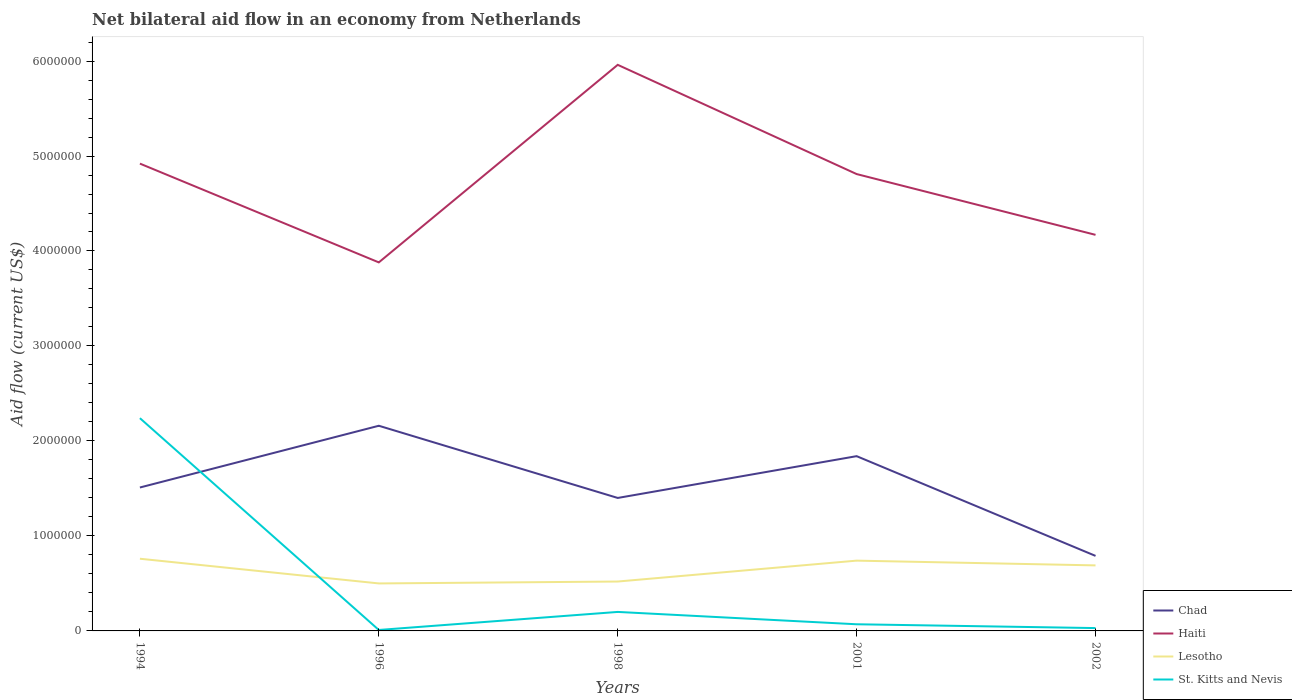How many different coloured lines are there?
Provide a short and direct response. 4. Is the number of lines equal to the number of legend labels?
Your response must be concise. Yes. Across all years, what is the maximum net bilateral aid flow in Haiti?
Provide a succinct answer. 3.88e+06. In which year was the net bilateral aid flow in Haiti maximum?
Keep it short and to the point. 1996. What is the total net bilateral aid flow in St. Kitts and Nevis in the graph?
Make the answer very short. 1.70e+05. What is the difference between the highest and the second highest net bilateral aid flow in St. Kitts and Nevis?
Offer a very short reply. 2.23e+06. What is the difference between the highest and the lowest net bilateral aid flow in Haiti?
Provide a succinct answer. 3. How many years are there in the graph?
Offer a terse response. 5. How many legend labels are there?
Offer a very short reply. 4. How are the legend labels stacked?
Your answer should be compact. Vertical. What is the title of the graph?
Ensure brevity in your answer.  Net bilateral aid flow in an economy from Netherlands. Does "Trinidad and Tobago" appear as one of the legend labels in the graph?
Keep it short and to the point. No. What is the label or title of the Y-axis?
Provide a short and direct response. Aid flow (current US$). What is the Aid flow (current US$) in Chad in 1994?
Ensure brevity in your answer.  1.51e+06. What is the Aid flow (current US$) in Haiti in 1994?
Offer a very short reply. 4.92e+06. What is the Aid flow (current US$) of Lesotho in 1994?
Your answer should be compact. 7.60e+05. What is the Aid flow (current US$) of St. Kitts and Nevis in 1994?
Give a very brief answer. 2.24e+06. What is the Aid flow (current US$) of Chad in 1996?
Offer a very short reply. 2.16e+06. What is the Aid flow (current US$) of Haiti in 1996?
Your answer should be very brief. 3.88e+06. What is the Aid flow (current US$) in Lesotho in 1996?
Your response must be concise. 5.00e+05. What is the Aid flow (current US$) in St. Kitts and Nevis in 1996?
Your response must be concise. 10000. What is the Aid flow (current US$) in Chad in 1998?
Give a very brief answer. 1.40e+06. What is the Aid flow (current US$) of Haiti in 1998?
Provide a succinct answer. 5.96e+06. What is the Aid flow (current US$) in Lesotho in 1998?
Offer a terse response. 5.20e+05. What is the Aid flow (current US$) of St. Kitts and Nevis in 1998?
Make the answer very short. 2.00e+05. What is the Aid flow (current US$) in Chad in 2001?
Provide a short and direct response. 1.84e+06. What is the Aid flow (current US$) in Haiti in 2001?
Provide a short and direct response. 4.81e+06. What is the Aid flow (current US$) in Lesotho in 2001?
Offer a terse response. 7.40e+05. What is the Aid flow (current US$) in Chad in 2002?
Provide a succinct answer. 7.90e+05. What is the Aid flow (current US$) in Haiti in 2002?
Provide a short and direct response. 4.17e+06. What is the Aid flow (current US$) in Lesotho in 2002?
Your answer should be compact. 6.90e+05. Across all years, what is the maximum Aid flow (current US$) of Chad?
Your response must be concise. 2.16e+06. Across all years, what is the maximum Aid flow (current US$) of Haiti?
Your response must be concise. 5.96e+06. Across all years, what is the maximum Aid flow (current US$) in Lesotho?
Provide a short and direct response. 7.60e+05. Across all years, what is the maximum Aid flow (current US$) in St. Kitts and Nevis?
Offer a very short reply. 2.24e+06. Across all years, what is the minimum Aid flow (current US$) in Chad?
Provide a succinct answer. 7.90e+05. Across all years, what is the minimum Aid flow (current US$) of Haiti?
Give a very brief answer. 3.88e+06. Across all years, what is the minimum Aid flow (current US$) in Lesotho?
Your answer should be very brief. 5.00e+05. What is the total Aid flow (current US$) in Chad in the graph?
Offer a very short reply. 7.70e+06. What is the total Aid flow (current US$) of Haiti in the graph?
Your answer should be very brief. 2.37e+07. What is the total Aid flow (current US$) in Lesotho in the graph?
Your response must be concise. 3.21e+06. What is the total Aid flow (current US$) of St. Kitts and Nevis in the graph?
Your response must be concise. 2.55e+06. What is the difference between the Aid flow (current US$) in Chad in 1994 and that in 1996?
Make the answer very short. -6.50e+05. What is the difference between the Aid flow (current US$) of Haiti in 1994 and that in 1996?
Provide a short and direct response. 1.04e+06. What is the difference between the Aid flow (current US$) in St. Kitts and Nevis in 1994 and that in 1996?
Provide a succinct answer. 2.23e+06. What is the difference between the Aid flow (current US$) of Chad in 1994 and that in 1998?
Offer a terse response. 1.10e+05. What is the difference between the Aid flow (current US$) in Haiti in 1994 and that in 1998?
Make the answer very short. -1.04e+06. What is the difference between the Aid flow (current US$) of St. Kitts and Nevis in 1994 and that in 1998?
Provide a short and direct response. 2.04e+06. What is the difference between the Aid flow (current US$) of Chad in 1994 and that in 2001?
Your answer should be very brief. -3.30e+05. What is the difference between the Aid flow (current US$) of Haiti in 1994 and that in 2001?
Offer a very short reply. 1.10e+05. What is the difference between the Aid flow (current US$) in Lesotho in 1994 and that in 2001?
Make the answer very short. 2.00e+04. What is the difference between the Aid flow (current US$) of St. Kitts and Nevis in 1994 and that in 2001?
Offer a terse response. 2.17e+06. What is the difference between the Aid flow (current US$) in Chad in 1994 and that in 2002?
Your answer should be very brief. 7.20e+05. What is the difference between the Aid flow (current US$) in Haiti in 1994 and that in 2002?
Ensure brevity in your answer.  7.50e+05. What is the difference between the Aid flow (current US$) of Lesotho in 1994 and that in 2002?
Offer a terse response. 7.00e+04. What is the difference between the Aid flow (current US$) in St. Kitts and Nevis in 1994 and that in 2002?
Provide a succinct answer. 2.21e+06. What is the difference between the Aid flow (current US$) of Chad in 1996 and that in 1998?
Provide a succinct answer. 7.60e+05. What is the difference between the Aid flow (current US$) of Haiti in 1996 and that in 1998?
Provide a succinct answer. -2.08e+06. What is the difference between the Aid flow (current US$) of Lesotho in 1996 and that in 1998?
Give a very brief answer. -2.00e+04. What is the difference between the Aid flow (current US$) of St. Kitts and Nevis in 1996 and that in 1998?
Offer a terse response. -1.90e+05. What is the difference between the Aid flow (current US$) of Chad in 1996 and that in 2001?
Your response must be concise. 3.20e+05. What is the difference between the Aid flow (current US$) of Haiti in 1996 and that in 2001?
Give a very brief answer. -9.30e+05. What is the difference between the Aid flow (current US$) in Lesotho in 1996 and that in 2001?
Your answer should be compact. -2.40e+05. What is the difference between the Aid flow (current US$) of Chad in 1996 and that in 2002?
Keep it short and to the point. 1.37e+06. What is the difference between the Aid flow (current US$) of Haiti in 1996 and that in 2002?
Give a very brief answer. -2.90e+05. What is the difference between the Aid flow (current US$) of Lesotho in 1996 and that in 2002?
Provide a succinct answer. -1.90e+05. What is the difference between the Aid flow (current US$) in Chad in 1998 and that in 2001?
Provide a short and direct response. -4.40e+05. What is the difference between the Aid flow (current US$) of Haiti in 1998 and that in 2001?
Your answer should be very brief. 1.15e+06. What is the difference between the Aid flow (current US$) in Lesotho in 1998 and that in 2001?
Your response must be concise. -2.20e+05. What is the difference between the Aid flow (current US$) in Chad in 1998 and that in 2002?
Make the answer very short. 6.10e+05. What is the difference between the Aid flow (current US$) in Haiti in 1998 and that in 2002?
Your answer should be compact. 1.79e+06. What is the difference between the Aid flow (current US$) of St. Kitts and Nevis in 1998 and that in 2002?
Provide a short and direct response. 1.70e+05. What is the difference between the Aid flow (current US$) of Chad in 2001 and that in 2002?
Keep it short and to the point. 1.05e+06. What is the difference between the Aid flow (current US$) in Haiti in 2001 and that in 2002?
Your answer should be compact. 6.40e+05. What is the difference between the Aid flow (current US$) of St. Kitts and Nevis in 2001 and that in 2002?
Your response must be concise. 4.00e+04. What is the difference between the Aid flow (current US$) in Chad in 1994 and the Aid flow (current US$) in Haiti in 1996?
Make the answer very short. -2.37e+06. What is the difference between the Aid flow (current US$) of Chad in 1994 and the Aid flow (current US$) of Lesotho in 1996?
Keep it short and to the point. 1.01e+06. What is the difference between the Aid flow (current US$) in Chad in 1994 and the Aid flow (current US$) in St. Kitts and Nevis in 1996?
Provide a short and direct response. 1.50e+06. What is the difference between the Aid flow (current US$) in Haiti in 1994 and the Aid flow (current US$) in Lesotho in 1996?
Offer a terse response. 4.42e+06. What is the difference between the Aid flow (current US$) in Haiti in 1994 and the Aid flow (current US$) in St. Kitts and Nevis in 1996?
Keep it short and to the point. 4.91e+06. What is the difference between the Aid flow (current US$) in Lesotho in 1994 and the Aid flow (current US$) in St. Kitts and Nevis in 1996?
Your response must be concise. 7.50e+05. What is the difference between the Aid flow (current US$) in Chad in 1994 and the Aid flow (current US$) in Haiti in 1998?
Give a very brief answer. -4.45e+06. What is the difference between the Aid flow (current US$) of Chad in 1994 and the Aid flow (current US$) of Lesotho in 1998?
Keep it short and to the point. 9.90e+05. What is the difference between the Aid flow (current US$) of Chad in 1994 and the Aid flow (current US$) of St. Kitts and Nevis in 1998?
Provide a succinct answer. 1.31e+06. What is the difference between the Aid flow (current US$) of Haiti in 1994 and the Aid flow (current US$) of Lesotho in 1998?
Your answer should be very brief. 4.40e+06. What is the difference between the Aid flow (current US$) in Haiti in 1994 and the Aid flow (current US$) in St. Kitts and Nevis in 1998?
Your answer should be very brief. 4.72e+06. What is the difference between the Aid flow (current US$) in Lesotho in 1994 and the Aid flow (current US$) in St. Kitts and Nevis in 1998?
Give a very brief answer. 5.60e+05. What is the difference between the Aid flow (current US$) in Chad in 1994 and the Aid flow (current US$) in Haiti in 2001?
Keep it short and to the point. -3.30e+06. What is the difference between the Aid flow (current US$) in Chad in 1994 and the Aid flow (current US$) in Lesotho in 2001?
Provide a short and direct response. 7.70e+05. What is the difference between the Aid flow (current US$) of Chad in 1994 and the Aid flow (current US$) of St. Kitts and Nevis in 2001?
Provide a succinct answer. 1.44e+06. What is the difference between the Aid flow (current US$) of Haiti in 1994 and the Aid flow (current US$) of Lesotho in 2001?
Provide a short and direct response. 4.18e+06. What is the difference between the Aid flow (current US$) in Haiti in 1994 and the Aid flow (current US$) in St. Kitts and Nevis in 2001?
Provide a short and direct response. 4.85e+06. What is the difference between the Aid flow (current US$) of Lesotho in 1994 and the Aid flow (current US$) of St. Kitts and Nevis in 2001?
Give a very brief answer. 6.90e+05. What is the difference between the Aid flow (current US$) in Chad in 1994 and the Aid flow (current US$) in Haiti in 2002?
Give a very brief answer. -2.66e+06. What is the difference between the Aid flow (current US$) of Chad in 1994 and the Aid flow (current US$) of Lesotho in 2002?
Your answer should be compact. 8.20e+05. What is the difference between the Aid flow (current US$) of Chad in 1994 and the Aid flow (current US$) of St. Kitts and Nevis in 2002?
Offer a very short reply. 1.48e+06. What is the difference between the Aid flow (current US$) of Haiti in 1994 and the Aid flow (current US$) of Lesotho in 2002?
Keep it short and to the point. 4.23e+06. What is the difference between the Aid flow (current US$) in Haiti in 1994 and the Aid flow (current US$) in St. Kitts and Nevis in 2002?
Offer a very short reply. 4.89e+06. What is the difference between the Aid flow (current US$) of Lesotho in 1994 and the Aid flow (current US$) of St. Kitts and Nevis in 2002?
Make the answer very short. 7.30e+05. What is the difference between the Aid flow (current US$) of Chad in 1996 and the Aid flow (current US$) of Haiti in 1998?
Your response must be concise. -3.80e+06. What is the difference between the Aid flow (current US$) of Chad in 1996 and the Aid flow (current US$) of Lesotho in 1998?
Provide a succinct answer. 1.64e+06. What is the difference between the Aid flow (current US$) of Chad in 1996 and the Aid flow (current US$) of St. Kitts and Nevis in 1998?
Offer a very short reply. 1.96e+06. What is the difference between the Aid flow (current US$) of Haiti in 1996 and the Aid flow (current US$) of Lesotho in 1998?
Provide a succinct answer. 3.36e+06. What is the difference between the Aid flow (current US$) of Haiti in 1996 and the Aid flow (current US$) of St. Kitts and Nevis in 1998?
Provide a succinct answer. 3.68e+06. What is the difference between the Aid flow (current US$) in Lesotho in 1996 and the Aid flow (current US$) in St. Kitts and Nevis in 1998?
Your answer should be very brief. 3.00e+05. What is the difference between the Aid flow (current US$) in Chad in 1996 and the Aid flow (current US$) in Haiti in 2001?
Offer a very short reply. -2.65e+06. What is the difference between the Aid flow (current US$) in Chad in 1996 and the Aid flow (current US$) in Lesotho in 2001?
Give a very brief answer. 1.42e+06. What is the difference between the Aid flow (current US$) of Chad in 1996 and the Aid flow (current US$) of St. Kitts and Nevis in 2001?
Make the answer very short. 2.09e+06. What is the difference between the Aid flow (current US$) in Haiti in 1996 and the Aid flow (current US$) in Lesotho in 2001?
Provide a short and direct response. 3.14e+06. What is the difference between the Aid flow (current US$) of Haiti in 1996 and the Aid flow (current US$) of St. Kitts and Nevis in 2001?
Your response must be concise. 3.81e+06. What is the difference between the Aid flow (current US$) in Lesotho in 1996 and the Aid flow (current US$) in St. Kitts and Nevis in 2001?
Provide a succinct answer. 4.30e+05. What is the difference between the Aid flow (current US$) in Chad in 1996 and the Aid flow (current US$) in Haiti in 2002?
Offer a very short reply. -2.01e+06. What is the difference between the Aid flow (current US$) in Chad in 1996 and the Aid flow (current US$) in Lesotho in 2002?
Offer a very short reply. 1.47e+06. What is the difference between the Aid flow (current US$) in Chad in 1996 and the Aid flow (current US$) in St. Kitts and Nevis in 2002?
Ensure brevity in your answer.  2.13e+06. What is the difference between the Aid flow (current US$) of Haiti in 1996 and the Aid flow (current US$) of Lesotho in 2002?
Ensure brevity in your answer.  3.19e+06. What is the difference between the Aid flow (current US$) in Haiti in 1996 and the Aid flow (current US$) in St. Kitts and Nevis in 2002?
Ensure brevity in your answer.  3.85e+06. What is the difference between the Aid flow (current US$) in Chad in 1998 and the Aid flow (current US$) in Haiti in 2001?
Give a very brief answer. -3.41e+06. What is the difference between the Aid flow (current US$) of Chad in 1998 and the Aid flow (current US$) of St. Kitts and Nevis in 2001?
Give a very brief answer. 1.33e+06. What is the difference between the Aid flow (current US$) in Haiti in 1998 and the Aid flow (current US$) in Lesotho in 2001?
Keep it short and to the point. 5.22e+06. What is the difference between the Aid flow (current US$) in Haiti in 1998 and the Aid flow (current US$) in St. Kitts and Nevis in 2001?
Offer a very short reply. 5.89e+06. What is the difference between the Aid flow (current US$) in Chad in 1998 and the Aid flow (current US$) in Haiti in 2002?
Offer a terse response. -2.77e+06. What is the difference between the Aid flow (current US$) in Chad in 1998 and the Aid flow (current US$) in Lesotho in 2002?
Your answer should be very brief. 7.10e+05. What is the difference between the Aid flow (current US$) in Chad in 1998 and the Aid flow (current US$) in St. Kitts and Nevis in 2002?
Ensure brevity in your answer.  1.37e+06. What is the difference between the Aid flow (current US$) of Haiti in 1998 and the Aid flow (current US$) of Lesotho in 2002?
Offer a very short reply. 5.27e+06. What is the difference between the Aid flow (current US$) in Haiti in 1998 and the Aid flow (current US$) in St. Kitts and Nevis in 2002?
Keep it short and to the point. 5.93e+06. What is the difference between the Aid flow (current US$) in Lesotho in 1998 and the Aid flow (current US$) in St. Kitts and Nevis in 2002?
Your answer should be compact. 4.90e+05. What is the difference between the Aid flow (current US$) of Chad in 2001 and the Aid flow (current US$) of Haiti in 2002?
Your answer should be very brief. -2.33e+06. What is the difference between the Aid flow (current US$) in Chad in 2001 and the Aid flow (current US$) in Lesotho in 2002?
Make the answer very short. 1.15e+06. What is the difference between the Aid flow (current US$) of Chad in 2001 and the Aid flow (current US$) of St. Kitts and Nevis in 2002?
Ensure brevity in your answer.  1.81e+06. What is the difference between the Aid flow (current US$) of Haiti in 2001 and the Aid flow (current US$) of Lesotho in 2002?
Your response must be concise. 4.12e+06. What is the difference between the Aid flow (current US$) in Haiti in 2001 and the Aid flow (current US$) in St. Kitts and Nevis in 2002?
Keep it short and to the point. 4.78e+06. What is the difference between the Aid flow (current US$) in Lesotho in 2001 and the Aid flow (current US$) in St. Kitts and Nevis in 2002?
Make the answer very short. 7.10e+05. What is the average Aid flow (current US$) of Chad per year?
Ensure brevity in your answer.  1.54e+06. What is the average Aid flow (current US$) in Haiti per year?
Offer a terse response. 4.75e+06. What is the average Aid flow (current US$) of Lesotho per year?
Offer a terse response. 6.42e+05. What is the average Aid flow (current US$) of St. Kitts and Nevis per year?
Keep it short and to the point. 5.10e+05. In the year 1994, what is the difference between the Aid flow (current US$) in Chad and Aid flow (current US$) in Haiti?
Make the answer very short. -3.41e+06. In the year 1994, what is the difference between the Aid flow (current US$) in Chad and Aid flow (current US$) in Lesotho?
Keep it short and to the point. 7.50e+05. In the year 1994, what is the difference between the Aid flow (current US$) of Chad and Aid flow (current US$) of St. Kitts and Nevis?
Keep it short and to the point. -7.30e+05. In the year 1994, what is the difference between the Aid flow (current US$) of Haiti and Aid flow (current US$) of Lesotho?
Make the answer very short. 4.16e+06. In the year 1994, what is the difference between the Aid flow (current US$) of Haiti and Aid flow (current US$) of St. Kitts and Nevis?
Your answer should be compact. 2.68e+06. In the year 1994, what is the difference between the Aid flow (current US$) in Lesotho and Aid flow (current US$) in St. Kitts and Nevis?
Your answer should be compact. -1.48e+06. In the year 1996, what is the difference between the Aid flow (current US$) in Chad and Aid flow (current US$) in Haiti?
Keep it short and to the point. -1.72e+06. In the year 1996, what is the difference between the Aid flow (current US$) of Chad and Aid flow (current US$) of Lesotho?
Your response must be concise. 1.66e+06. In the year 1996, what is the difference between the Aid flow (current US$) in Chad and Aid flow (current US$) in St. Kitts and Nevis?
Provide a succinct answer. 2.15e+06. In the year 1996, what is the difference between the Aid flow (current US$) in Haiti and Aid flow (current US$) in Lesotho?
Keep it short and to the point. 3.38e+06. In the year 1996, what is the difference between the Aid flow (current US$) in Haiti and Aid flow (current US$) in St. Kitts and Nevis?
Your answer should be compact. 3.87e+06. In the year 1998, what is the difference between the Aid flow (current US$) of Chad and Aid flow (current US$) of Haiti?
Provide a succinct answer. -4.56e+06. In the year 1998, what is the difference between the Aid flow (current US$) of Chad and Aid flow (current US$) of Lesotho?
Give a very brief answer. 8.80e+05. In the year 1998, what is the difference between the Aid flow (current US$) in Chad and Aid flow (current US$) in St. Kitts and Nevis?
Offer a very short reply. 1.20e+06. In the year 1998, what is the difference between the Aid flow (current US$) of Haiti and Aid flow (current US$) of Lesotho?
Offer a very short reply. 5.44e+06. In the year 1998, what is the difference between the Aid flow (current US$) of Haiti and Aid flow (current US$) of St. Kitts and Nevis?
Offer a terse response. 5.76e+06. In the year 2001, what is the difference between the Aid flow (current US$) in Chad and Aid flow (current US$) in Haiti?
Provide a short and direct response. -2.97e+06. In the year 2001, what is the difference between the Aid flow (current US$) in Chad and Aid flow (current US$) in Lesotho?
Give a very brief answer. 1.10e+06. In the year 2001, what is the difference between the Aid flow (current US$) of Chad and Aid flow (current US$) of St. Kitts and Nevis?
Offer a terse response. 1.77e+06. In the year 2001, what is the difference between the Aid flow (current US$) of Haiti and Aid flow (current US$) of Lesotho?
Your answer should be compact. 4.07e+06. In the year 2001, what is the difference between the Aid flow (current US$) of Haiti and Aid flow (current US$) of St. Kitts and Nevis?
Provide a short and direct response. 4.74e+06. In the year 2001, what is the difference between the Aid flow (current US$) of Lesotho and Aid flow (current US$) of St. Kitts and Nevis?
Give a very brief answer. 6.70e+05. In the year 2002, what is the difference between the Aid flow (current US$) of Chad and Aid flow (current US$) of Haiti?
Provide a short and direct response. -3.38e+06. In the year 2002, what is the difference between the Aid flow (current US$) in Chad and Aid flow (current US$) in Lesotho?
Your answer should be very brief. 1.00e+05. In the year 2002, what is the difference between the Aid flow (current US$) in Chad and Aid flow (current US$) in St. Kitts and Nevis?
Your answer should be very brief. 7.60e+05. In the year 2002, what is the difference between the Aid flow (current US$) of Haiti and Aid flow (current US$) of Lesotho?
Provide a succinct answer. 3.48e+06. In the year 2002, what is the difference between the Aid flow (current US$) of Haiti and Aid flow (current US$) of St. Kitts and Nevis?
Offer a terse response. 4.14e+06. In the year 2002, what is the difference between the Aid flow (current US$) of Lesotho and Aid flow (current US$) of St. Kitts and Nevis?
Offer a very short reply. 6.60e+05. What is the ratio of the Aid flow (current US$) of Chad in 1994 to that in 1996?
Offer a very short reply. 0.7. What is the ratio of the Aid flow (current US$) of Haiti in 1994 to that in 1996?
Offer a terse response. 1.27. What is the ratio of the Aid flow (current US$) of Lesotho in 1994 to that in 1996?
Your response must be concise. 1.52. What is the ratio of the Aid flow (current US$) of St. Kitts and Nevis in 1994 to that in 1996?
Give a very brief answer. 224. What is the ratio of the Aid flow (current US$) of Chad in 1994 to that in 1998?
Keep it short and to the point. 1.08. What is the ratio of the Aid flow (current US$) of Haiti in 1994 to that in 1998?
Give a very brief answer. 0.83. What is the ratio of the Aid flow (current US$) of Lesotho in 1994 to that in 1998?
Your response must be concise. 1.46. What is the ratio of the Aid flow (current US$) in Chad in 1994 to that in 2001?
Your response must be concise. 0.82. What is the ratio of the Aid flow (current US$) of Haiti in 1994 to that in 2001?
Make the answer very short. 1.02. What is the ratio of the Aid flow (current US$) in Lesotho in 1994 to that in 2001?
Provide a succinct answer. 1.03. What is the ratio of the Aid flow (current US$) in Chad in 1994 to that in 2002?
Offer a very short reply. 1.91. What is the ratio of the Aid flow (current US$) of Haiti in 1994 to that in 2002?
Provide a short and direct response. 1.18. What is the ratio of the Aid flow (current US$) of Lesotho in 1994 to that in 2002?
Offer a terse response. 1.1. What is the ratio of the Aid flow (current US$) of St. Kitts and Nevis in 1994 to that in 2002?
Give a very brief answer. 74.67. What is the ratio of the Aid flow (current US$) in Chad in 1996 to that in 1998?
Provide a succinct answer. 1.54. What is the ratio of the Aid flow (current US$) in Haiti in 1996 to that in 1998?
Your answer should be very brief. 0.65. What is the ratio of the Aid flow (current US$) in Lesotho in 1996 to that in 1998?
Your response must be concise. 0.96. What is the ratio of the Aid flow (current US$) of Chad in 1996 to that in 2001?
Make the answer very short. 1.17. What is the ratio of the Aid flow (current US$) in Haiti in 1996 to that in 2001?
Keep it short and to the point. 0.81. What is the ratio of the Aid flow (current US$) in Lesotho in 1996 to that in 2001?
Give a very brief answer. 0.68. What is the ratio of the Aid flow (current US$) of St. Kitts and Nevis in 1996 to that in 2001?
Your response must be concise. 0.14. What is the ratio of the Aid flow (current US$) of Chad in 1996 to that in 2002?
Provide a short and direct response. 2.73. What is the ratio of the Aid flow (current US$) of Haiti in 1996 to that in 2002?
Offer a very short reply. 0.93. What is the ratio of the Aid flow (current US$) of Lesotho in 1996 to that in 2002?
Your response must be concise. 0.72. What is the ratio of the Aid flow (current US$) in Chad in 1998 to that in 2001?
Your answer should be very brief. 0.76. What is the ratio of the Aid flow (current US$) of Haiti in 1998 to that in 2001?
Keep it short and to the point. 1.24. What is the ratio of the Aid flow (current US$) in Lesotho in 1998 to that in 2001?
Give a very brief answer. 0.7. What is the ratio of the Aid flow (current US$) in St. Kitts and Nevis in 1998 to that in 2001?
Make the answer very short. 2.86. What is the ratio of the Aid flow (current US$) in Chad in 1998 to that in 2002?
Keep it short and to the point. 1.77. What is the ratio of the Aid flow (current US$) of Haiti in 1998 to that in 2002?
Keep it short and to the point. 1.43. What is the ratio of the Aid flow (current US$) in Lesotho in 1998 to that in 2002?
Provide a short and direct response. 0.75. What is the ratio of the Aid flow (current US$) of Chad in 2001 to that in 2002?
Ensure brevity in your answer.  2.33. What is the ratio of the Aid flow (current US$) of Haiti in 2001 to that in 2002?
Your answer should be compact. 1.15. What is the ratio of the Aid flow (current US$) in Lesotho in 2001 to that in 2002?
Offer a terse response. 1.07. What is the ratio of the Aid flow (current US$) in St. Kitts and Nevis in 2001 to that in 2002?
Provide a short and direct response. 2.33. What is the difference between the highest and the second highest Aid flow (current US$) in Chad?
Give a very brief answer. 3.20e+05. What is the difference between the highest and the second highest Aid flow (current US$) of Haiti?
Keep it short and to the point. 1.04e+06. What is the difference between the highest and the second highest Aid flow (current US$) in Lesotho?
Offer a very short reply. 2.00e+04. What is the difference between the highest and the second highest Aid flow (current US$) of St. Kitts and Nevis?
Your response must be concise. 2.04e+06. What is the difference between the highest and the lowest Aid flow (current US$) of Chad?
Your answer should be compact. 1.37e+06. What is the difference between the highest and the lowest Aid flow (current US$) of Haiti?
Give a very brief answer. 2.08e+06. What is the difference between the highest and the lowest Aid flow (current US$) of St. Kitts and Nevis?
Keep it short and to the point. 2.23e+06. 